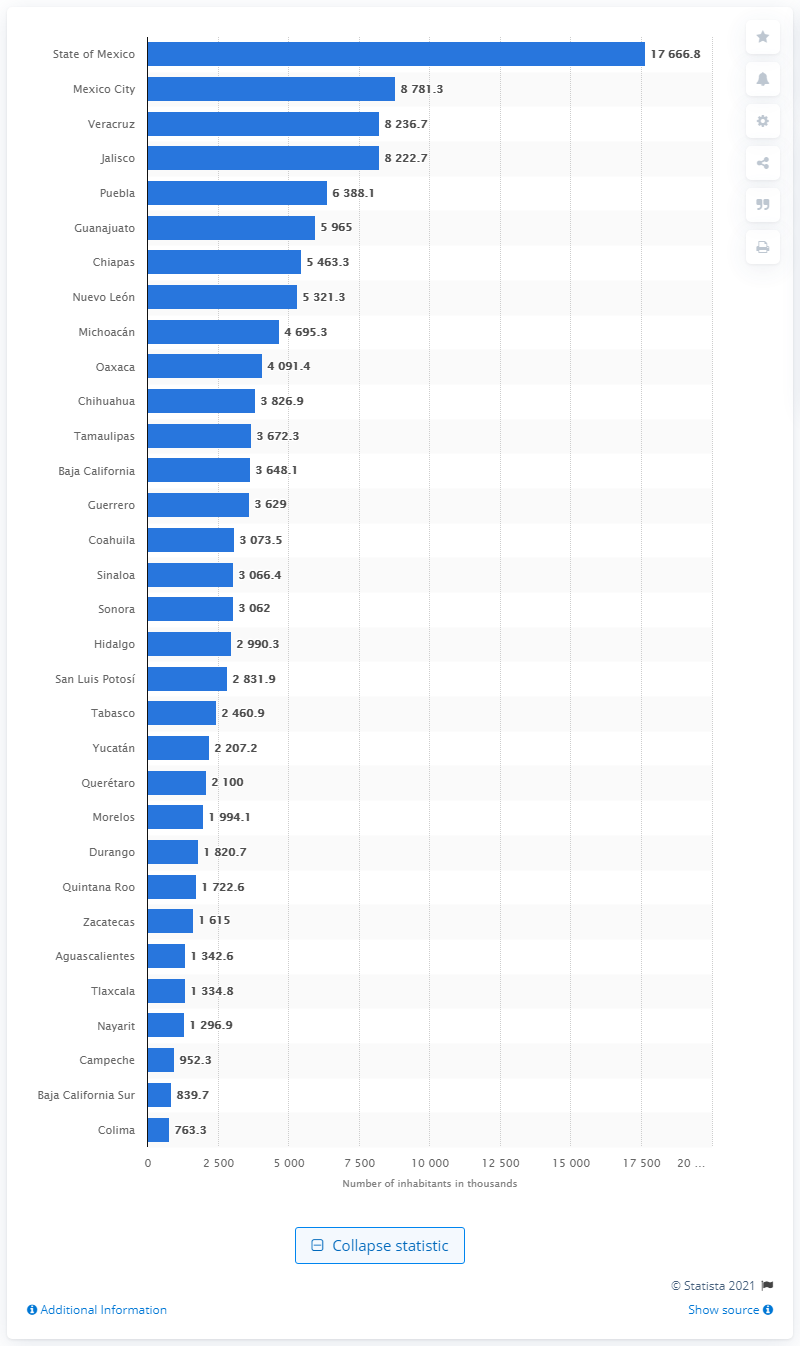Identify some key points in this picture. According to the data, Colima was the state with the lowest population among all the others. 